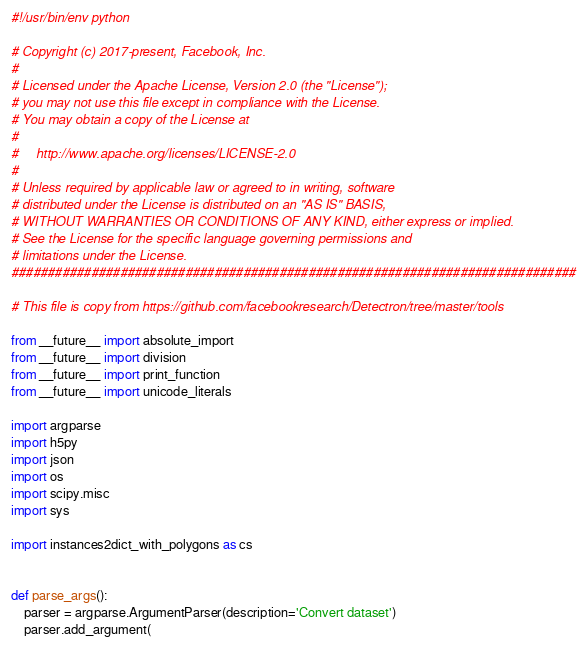Convert code to text. <code><loc_0><loc_0><loc_500><loc_500><_Python_>#!/usr/bin/env python

# Copyright (c) 2017-present, Facebook, Inc.
#
# Licensed under the Apache License, Version 2.0 (the "License");
# you may not use this file except in compliance with the License.
# You may obtain a copy of the License at
#
#     http://www.apache.org/licenses/LICENSE-2.0
#
# Unless required by applicable law or agreed to in writing, software
# distributed under the License is distributed on an "AS IS" BASIS,
# WITHOUT WARRANTIES OR CONDITIONS OF ANY KIND, either express or implied.
# See the License for the specific language governing permissions and
# limitations under the License.
##############################################################################

# This file is copy from https://github.com/facebookresearch/Detectron/tree/master/tools

from __future__ import absolute_import
from __future__ import division
from __future__ import print_function
from __future__ import unicode_literals

import argparse
import h5py
import json
import os
import scipy.misc
import sys

import instances2dict_with_polygons as cs


def parse_args():
    parser = argparse.ArgumentParser(description='Convert dataset')
    parser.add_argument(</code> 